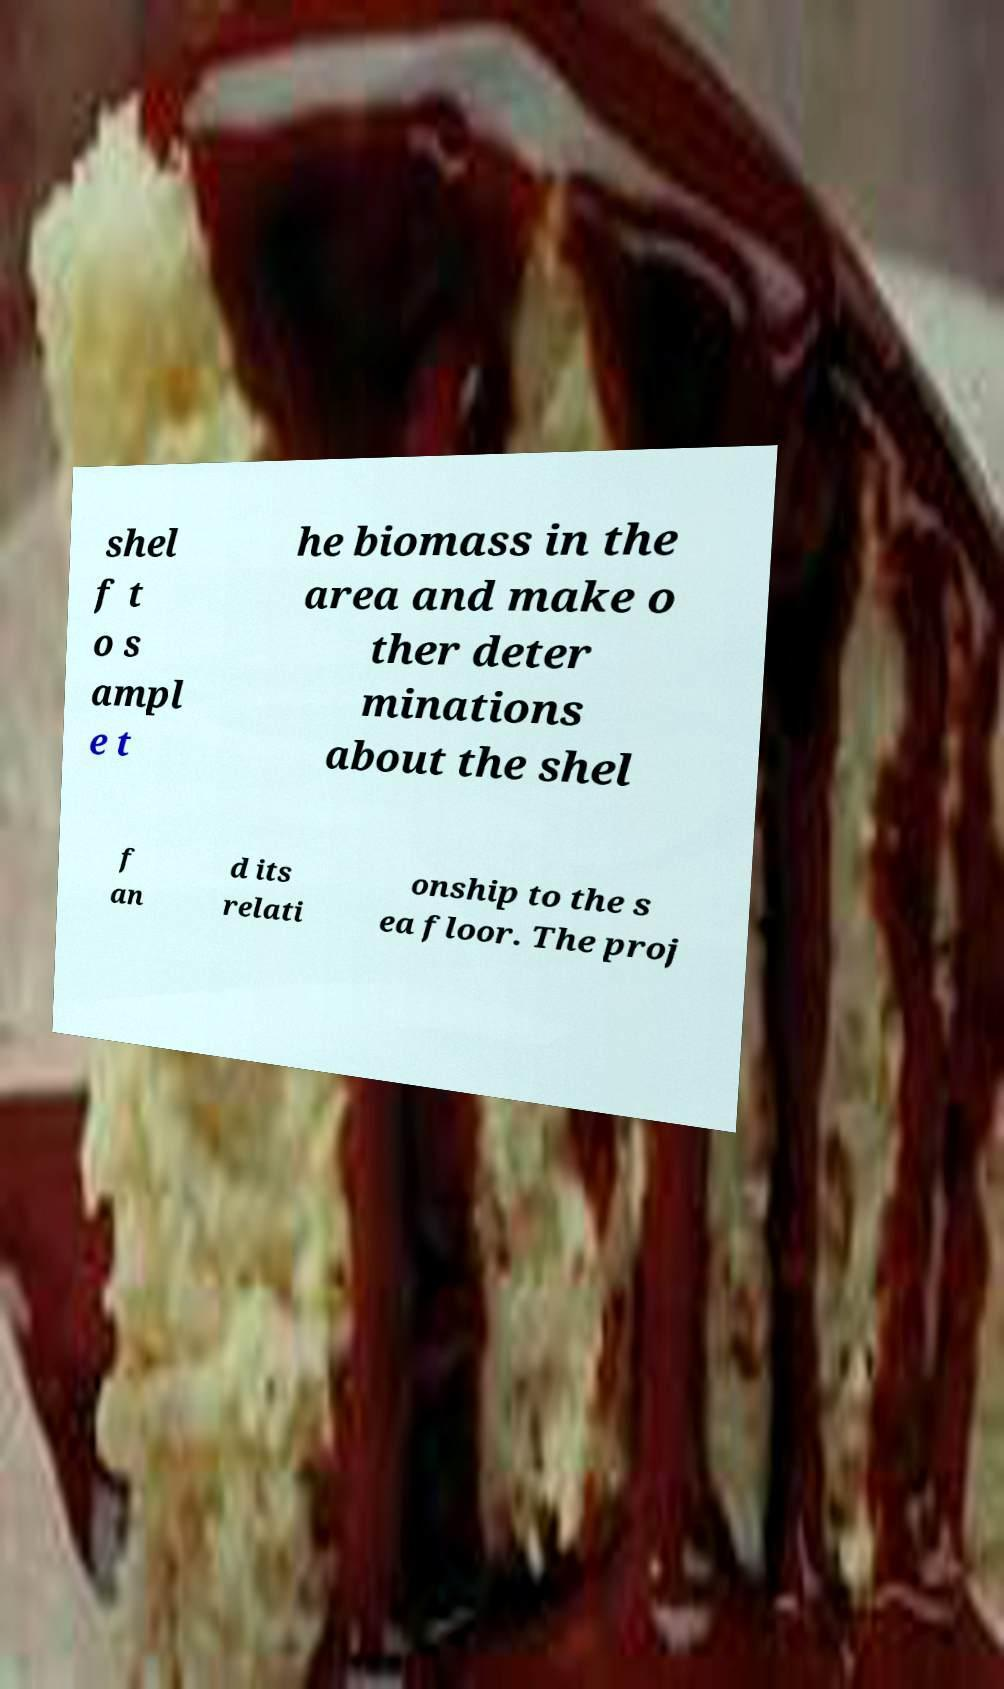Can you read and provide the text displayed in the image?This photo seems to have some interesting text. Can you extract and type it out for me? shel f t o s ampl e t he biomass in the area and make o ther deter minations about the shel f an d its relati onship to the s ea floor. The proj 